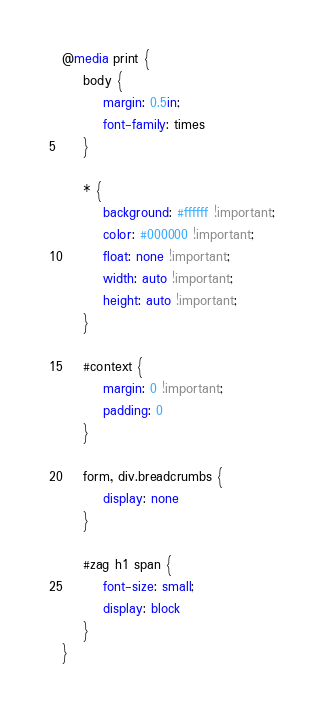Convert code to text. <code><loc_0><loc_0><loc_500><loc_500><_CSS_>@media print {
    body {
        margin: 0.5in;
        font-family: times
    }

    * {
        background: #ffffff !important;
        color: #000000 !important;
        float: none !important;
        width: auto !important;
        height: auto !important;
    }

    #context {
        margin: 0 !important;
        padding: 0
    }

    form, div.breadcrumbs {
        display: none
    }

    #zag h1 span {
        font-size: small;
        display: block
    }
}</code> 